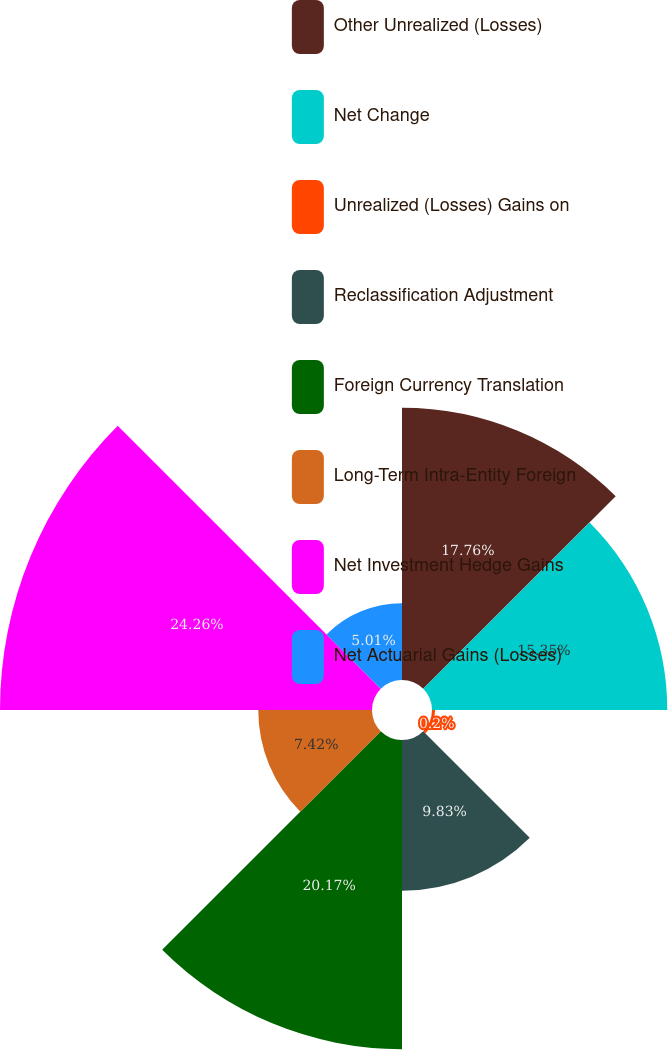Convert chart to OTSL. <chart><loc_0><loc_0><loc_500><loc_500><pie_chart><fcel>Other Unrealized (Losses)<fcel>Net Change<fcel>Unrealized (Losses) Gains on<fcel>Reclassification Adjustment<fcel>Foreign Currency Translation<fcel>Long-Term Intra-Entity Foreign<fcel>Net Investment Hedge Gains<fcel>Net Actuarial Gains (Losses)<nl><fcel>17.76%<fcel>15.35%<fcel>0.2%<fcel>9.83%<fcel>20.17%<fcel>7.42%<fcel>24.27%<fcel>5.01%<nl></chart> 